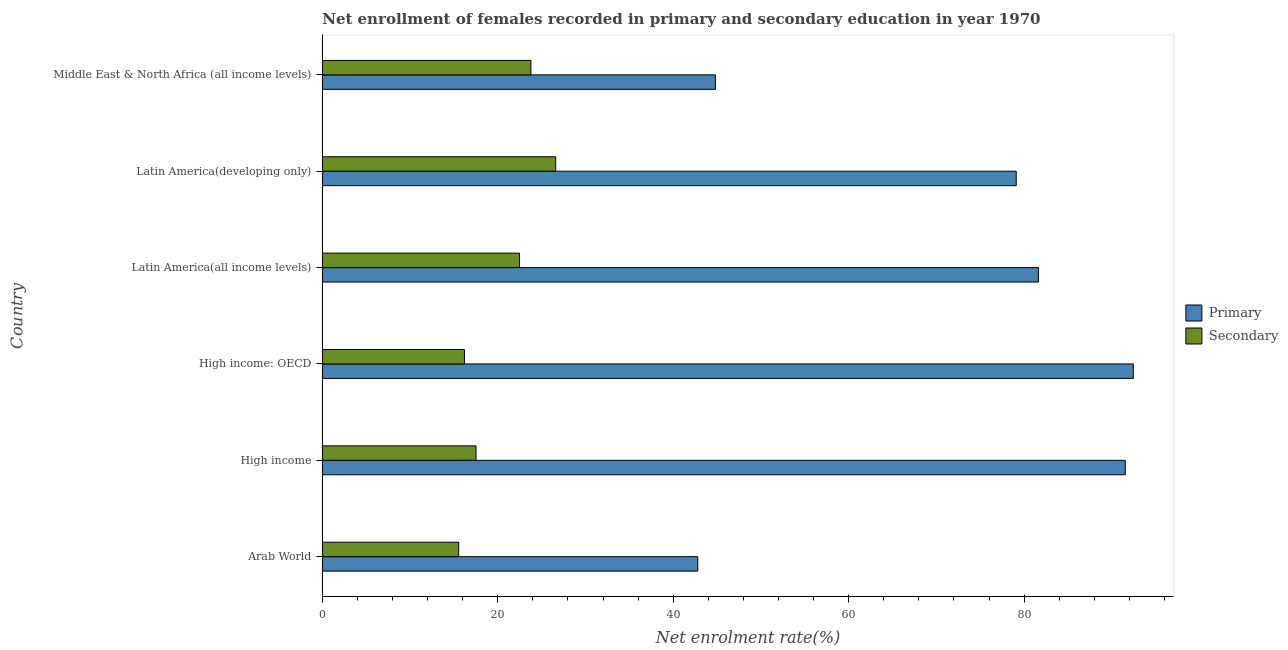How many different coloured bars are there?
Your answer should be compact. 2. Are the number of bars on each tick of the Y-axis equal?
Ensure brevity in your answer.  Yes. How many bars are there on the 2nd tick from the top?
Your answer should be very brief. 2. How many bars are there on the 6th tick from the bottom?
Offer a terse response. 2. What is the label of the 2nd group of bars from the top?
Offer a very short reply. Latin America(developing only). What is the enrollment rate in primary education in Arab World?
Give a very brief answer. 42.8. Across all countries, what is the maximum enrollment rate in primary education?
Give a very brief answer. 92.45. Across all countries, what is the minimum enrollment rate in secondary education?
Your answer should be very brief. 15.54. In which country was the enrollment rate in secondary education maximum?
Ensure brevity in your answer.  Latin America(developing only). In which country was the enrollment rate in primary education minimum?
Ensure brevity in your answer.  Arab World. What is the total enrollment rate in primary education in the graph?
Provide a succinct answer. 432.35. What is the difference between the enrollment rate in primary education in High income and that in Middle East & North Africa (all income levels)?
Keep it short and to the point. 46.72. What is the difference between the enrollment rate in primary education in High income and the enrollment rate in secondary education in Latin America(developing only)?
Offer a very short reply. 64.93. What is the average enrollment rate in primary education per country?
Offer a terse response. 72.06. What is the difference between the enrollment rate in primary education and enrollment rate in secondary education in Middle East & North Africa (all income levels)?
Your response must be concise. 21.04. In how many countries, is the enrollment rate in secondary education greater than 56 %?
Keep it short and to the point. 0. What is the ratio of the enrollment rate in secondary education in Latin America(all income levels) to that in Latin America(developing only)?
Your answer should be very brief. 0.84. Is the enrollment rate in secondary education in High income: OECD less than that in Middle East & North Africa (all income levels)?
Make the answer very short. Yes. What is the difference between the highest and the second highest enrollment rate in primary education?
Keep it short and to the point. 0.91. What is the difference between the highest and the lowest enrollment rate in primary education?
Ensure brevity in your answer.  49.65. What does the 2nd bar from the top in Latin America(all income levels) represents?
Offer a terse response. Primary. What does the 2nd bar from the bottom in Latin America(developing only) represents?
Offer a very short reply. Secondary. How many bars are there?
Give a very brief answer. 12. What is the difference between two consecutive major ticks on the X-axis?
Give a very brief answer. 20. Are the values on the major ticks of X-axis written in scientific E-notation?
Your answer should be compact. No. What is the title of the graph?
Keep it short and to the point. Net enrollment of females recorded in primary and secondary education in year 1970. Does "External balance on goods" appear as one of the legend labels in the graph?
Provide a short and direct response. No. What is the label or title of the X-axis?
Your response must be concise. Net enrolment rate(%). What is the Net enrolment rate(%) of Primary in Arab World?
Provide a short and direct response. 42.8. What is the Net enrolment rate(%) in Secondary in Arab World?
Your answer should be very brief. 15.54. What is the Net enrolment rate(%) in Primary in High income?
Your answer should be compact. 91.54. What is the Net enrolment rate(%) of Secondary in High income?
Your answer should be very brief. 17.52. What is the Net enrolment rate(%) in Primary in High income: OECD?
Offer a very short reply. 92.45. What is the Net enrolment rate(%) in Secondary in High income: OECD?
Give a very brief answer. 16.2. What is the Net enrolment rate(%) of Primary in Latin America(all income levels)?
Offer a terse response. 81.63. What is the Net enrolment rate(%) in Secondary in Latin America(all income levels)?
Your answer should be very brief. 22.48. What is the Net enrolment rate(%) in Primary in Latin America(developing only)?
Ensure brevity in your answer.  79.11. What is the Net enrolment rate(%) in Secondary in Latin America(developing only)?
Offer a very short reply. 26.61. What is the Net enrolment rate(%) of Primary in Middle East & North Africa (all income levels)?
Provide a succinct answer. 44.82. What is the Net enrolment rate(%) of Secondary in Middle East & North Africa (all income levels)?
Offer a very short reply. 23.78. Across all countries, what is the maximum Net enrolment rate(%) in Primary?
Make the answer very short. 92.45. Across all countries, what is the maximum Net enrolment rate(%) of Secondary?
Offer a terse response. 26.61. Across all countries, what is the minimum Net enrolment rate(%) in Primary?
Your answer should be compact. 42.8. Across all countries, what is the minimum Net enrolment rate(%) of Secondary?
Give a very brief answer. 15.54. What is the total Net enrolment rate(%) of Primary in the graph?
Your answer should be very brief. 432.35. What is the total Net enrolment rate(%) of Secondary in the graph?
Make the answer very short. 122.13. What is the difference between the Net enrolment rate(%) of Primary in Arab World and that in High income?
Your answer should be very brief. -48.73. What is the difference between the Net enrolment rate(%) of Secondary in Arab World and that in High income?
Ensure brevity in your answer.  -1.98. What is the difference between the Net enrolment rate(%) in Primary in Arab World and that in High income: OECD?
Provide a short and direct response. -49.65. What is the difference between the Net enrolment rate(%) in Secondary in Arab World and that in High income: OECD?
Provide a short and direct response. -0.66. What is the difference between the Net enrolment rate(%) of Primary in Arab World and that in Latin America(all income levels)?
Make the answer very short. -38.83. What is the difference between the Net enrolment rate(%) in Secondary in Arab World and that in Latin America(all income levels)?
Your answer should be compact. -6.94. What is the difference between the Net enrolment rate(%) of Primary in Arab World and that in Latin America(developing only)?
Offer a terse response. -36.3. What is the difference between the Net enrolment rate(%) of Secondary in Arab World and that in Latin America(developing only)?
Your answer should be very brief. -11.06. What is the difference between the Net enrolment rate(%) in Primary in Arab World and that in Middle East & North Africa (all income levels)?
Offer a terse response. -2.01. What is the difference between the Net enrolment rate(%) in Secondary in Arab World and that in Middle East & North Africa (all income levels)?
Offer a terse response. -8.23. What is the difference between the Net enrolment rate(%) of Primary in High income and that in High income: OECD?
Your answer should be very brief. -0.91. What is the difference between the Net enrolment rate(%) of Secondary in High income and that in High income: OECD?
Provide a succinct answer. 1.32. What is the difference between the Net enrolment rate(%) of Primary in High income and that in Latin America(all income levels)?
Make the answer very short. 9.9. What is the difference between the Net enrolment rate(%) of Secondary in High income and that in Latin America(all income levels)?
Make the answer very short. -4.96. What is the difference between the Net enrolment rate(%) of Primary in High income and that in Latin America(developing only)?
Give a very brief answer. 12.43. What is the difference between the Net enrolment rate(%) in Secondary in High income and that in Latin America(developing only)?
Keep it short and to the point. -9.09. What is the difference between the Net enrolment rate(%) in Primary in High income and that in Middle East & North Africa (all income levels)?
Provide a short and direct response. 46.72. What is the difference between the Net enrolment rate(%) of Secondary in High income and that in Middle East & North Africa (all income levels)?
Make the answer very short. -6.26. What is the difference between the Net enrolment rate(%) of Primary in High income: OECD and that in Latin America(all income levels)?
Offer a terse response. 10.82. What is the difference between the Net enrolment rate(%) in Secondary in High income: OECD and that in Latin America(all income levels)?
Provide a succinct answer. -6.28. What is the difference between the Net enrolment rate(%) in Primary in High income: OECD and that in Latin America(developing only)?
Offer a very short reply. 13.35. What is the difference between the Net enrolment rate(%) in Secondary in High income: OECD and that in Latin America(developing only)?
Your response must be concise. -10.4. What is the difference between the Net enrolment rate(%) in Primary in High income: OECD and that in Middle East & North Africa (all income levels)?
Give a very brief answer. 47.63. What is the difference between the Net enrolment rate(%) in Secondary in High income: OECD and that in Middle East & North Africa (all income levels)?
Keep it short and to the point. -7.58. What is the difference between the Net enrolment rate(%) of Primary in Latin America(all income levels) and that in Latin America(developing only)?
Offer a very short reply. 2.53. What is the difference between the Net enrolment rate(%) in Secondary in Latin America(all income levels) and that in Latin America(developing only)?
Keep it short and to the point. -4.12. What is the difference between the Net enrolment rate(%) in Primary in Latin America(all income levels) and that in Middle East & North Africa (all income levels)?
Give a very brief answer. 36.82. What is the difference between the Net enrolment rate(%) in Secondary in Latin America(all income levels) and that in Middle East & North Africa (all income levels)?
Make the answer very short. -1.3. What is the difference between the Net enrolment rate(%) of Primary in Latin America(developing only) and that in Middle East & North Africa (all income levels)?
Ensure brevity in your answer.  34.29. What is the difference between the Net enrolment rate(%) of Secondary in Latin America(developing only) and that in Middle East & North Africa (all income levels)?
Your answer should be compact. 2.83. What is the difference between the Net enrolment rate(%) of Primary in Arab World and the Net enrolment rate(%) of Secondary in High income?
Your answer should be very brief. 25.28. What is the difference between the Net enrolment rate(%) in Primary in Arab World and the Net enrolment rate(%) in Secondary in High income: OECD?
Your answer should be very brief. 26.6. What is the difference between the Net enrolment rate(%) of Primary in Arab World and the Net enrolment rate(%) of Secondary in Latin America(all income levels)?
Your response must be concise. 20.32. What is the difference between the Net enrolment rate(%) of Primary in Arab World and the Net enrolment rate(%) of Secondary in Latin America(developing only)?
Ensure brevity in your answer.  16.2. What is the difference between the Net enrolment rate(%) of Primary in Arab World and the Net enrolment rate(%) of Secondary in Middle East & North Africa (all income levels)?
Ensure brevity in your answer.  19.03. What is the difference between the Net enrolment rate(%) in Primary in High income and the Net enrolment rate(%) in Secondary in High income: OECD?
Give a very brief answer. 75.34. What is the difference between the Net enrolment rate(%) of Primary in High income and the Net enrolment rate(%) of Secondary in Latin America(all income levels)?
Provide a short and direct response. 69.06. What is the difference between the Net enrolment rate(%) in Primary in High income and the Net enrolment rate(%) in Secondary in Latin America(developing only)?
Give a very brief answer. 64.93. What is the difference between the Net enrolment rate(%) of Primary in High income and the Net enrolment rate(%) of Secondary in Middle East & North Africa (all income levels)?
Your answer should be very brief. 67.76. What is the difference between the Net enrolment rate(%) of Primary in High income: OECD and the Net enrolment rate(%) of Secondary in Latin America(all income levels)?
Make the answer very short. 69.97. What is the difference between the Net enrolment rate(%) of Primary in High income: OECD and the Net enrolment rate(%) of Secondary in Latin America(developing only)?
Your response must be concise. 65.85. What is the difference between the Net enrolment rate(%) in Primary in High income: OECD and the Net enrolment rate(%) in Secondary in Middle East & North Africa (all income levels)?
Your answer should be compact. 68.68. What is the difference between the Net enrolment rate(%) of Primary in Latin America(all income levels) and the Net enrolment rate(%) of Secondary in Latin America(developing only)?
Your response must be concise. 55.03. What is the difference between the Net enrolment rate(%) in Primary in Latin America(all income levels) and the Net enrolment rate(%) in Secondary in Middle East & North Africa (all income levels)?
Offer a terse response. 57.86. What is the difference between the Net enrolment rate(%) of Primary in Latin America(developing only) and the Net enrolment rate(%) of Secondary in Middle East & North Africa (all income levels)?
Your answer should be very brief. 55.33. What is the average Net enrolment rate(%) of Primary per country?
Your response must be concise. 72.06. What is the average Net enrolment rate(%) in Secondary per country?
Your response must be concise. 20.36. What is the difference between the Net enrolment rate(%) in Primary and Net enrolment rate(%) in Secondary in Arab World?
Make the answer very short. 27.26. What is the difference between the Net enrolment rate(%) in Primary and Net enrolment rate(%) in Secondary in High income?
Make the answer very short. 74.02. What is the difference between the Net enrolment rate(%) of Primary and Net enrolment rate(%) of Secondary in High income: OECD?
Offer a very short reply. 76.25. What is the difference between the Net enrolment rate(%) in Primary and Net enrolment rate(%) in Secondary in Latin America(all income levels)?
Provide a short and direct response. 59.15. What is the difference between the Net enrolment rate(%) in Primary and Net enrolment rate(%) in Secondary in Latin America(developing only)?
Provide a succinct answer. 52.5. What is the difference between the Net enrolment rate(%) in Primary and Net enrolment rate(%) in Secondary in Middle East & North Africa (all income levels)?
Offer a terse response. 21.04. What is the ratio of the Net enrolment rate(%) of Primary in Arab World to that in High income?
Offer a very short reply. 0.47. What is the ratio of the Net enrolment rate(%) in Secondary in Arab World to that in High income?
Your answer should be compact. 0.89. What is the ratio of the Net enrolment rate(%) in Primary in Arab World to that in High income: OECD?
Provide a short and direct response. 0.46. What is the ratio of the Net enrolment rate(%) in Secondary in Arab World to that in High income: OECD?
Give a very brief answer. 0.96. What is the ratio of the Net enrolment rate(%) in Primary in Arab World to that in Latin America(all income levels)?
Give a very brief answer. 0.52. What is the ratio of the Net enrolment rate(%) in Secondary in Arab World to that in Latin America(all income levels)?
Give a very brief answer. 0.69. What is the ratio of the Net enrolment rate(%) of Primary in Arab World to that in Latin America(developing only)?
Offer a terse response. 0.54. What is the ratio of the Net enrolment rate(%) of Secondary in Arab World to that in Latin America(developing only)?
Offer a very short reply. 0.58. What is the ratio of the Net enrolment rate(%) in Primary in Arab World to that in Middle East & North Africa (all income levels)?
Give a very brief answer. 0.96. What is the ratio of the Net enrolment rate(%) of Secondary in Arab World to that in Middle East & North Africa (all income levels)?
Offer a terse response. 0.65. What is the ratio of the Net enrolment rate(%) in Primary in High income to that in High income: OECD?
Your answer should be compact. 0.99. What is the ratio of the Net enrolment rate(%) of Secondary in High income to that in High income: OECD?
Provide a short and direct response. 1.08. What is the ratio of the Net enrolment rate(%) of Primary in High income to that in Latin America(all income levels)?
Keep it short and to the point. 1.12. What is the ratio of the Net enrolment rate(%) in Secondary in High income to that in Latin America(all income levels)?
Keep it short and to the point. 0.78. What is the ratio of the Net enrolment rate(%) of Primary in High income to that in Latin America(developing only)?
Offer a terse response. 1.16. What is the ratio of the Net enrolment rate(%) in Secondary in High income to that in Latin America(developing only)?
Give a very brief answer. 0.66. What is the ratio of the Net enrolment rate(%) of Primary in High income to that in Middle East & North Africa (all income levels)?
Provide a short and direct response. 2.04. What is the ratio of the Net enrolment rate(%) in Secondary in High income to that in Middle East & North Africa (all income levels)?
Provide a succinct answer. 0.74. What is the ratio of the Net enrolment rate(%) in Primary in High income: OECD to that in Latin America(all income levels)?
Offer a terse response. 1.13. What is the ratio of the Net enrolment rate(%) in Secondary in High income: OECD to that in Latin America(all income levels)?
Give a very brief answer. 0.72. What is the ratio of the Net enrolment rate(%) of Primary in High income: OECD to that in Latin America(developing only)?
Provide a short and direct response. 1.17. What is the ratio of the Net enrolment rate(%) of Secondary in High income: OECD to that in Latin America(developing only)?
Offer a terse response. 0.61. What is the ratio of the Net enrolment rate(%) in Primary in High income: OECD to that in Middle East & North Africa (all income levels)?
Offer a very short reply. 2.06. What is the ratio of the Net enrolment rate(%) of Secondary in High income: OECD to that in Middle East & North Africa (all income levels)?
Your answer should be compact. 0.68. What is the ratio of the Net enrolment rate(%) in Primary in Latin America(all income levels) to that in Latin America(developing only)?
Ensure brevity in your answer.  1.03. What is the ratio of the Net enrolment rate(%) of Secondary in Latin America(all income levels) to that in Latin America(developing only)?
Offer a very short reply. 0.84. What is the ratio of the Net enrolment rate(%) in Primary in Latin America(all income levels) to that in Middle East & North Africa (all income levels)?
Your answer should be very brief. 1.82. What is the ratio of the Net enrolment rate(%) in Secondary in Latin America(all income levels) to that in Middle East & North Africa (all income levels)?
Offer a very short reply. 0.95. What is the ratio of the Net enrolment rate(%) in Primary in Latin America(developing only) to that in Middle East & North Africa (all income levels)?
Offer a terse response. 1.76. What is the ratio of the Net enrolment rate(%) of Secondary in Latin America(developing only) to that in Middle East & North Africa (all income levels)?
Make the answer very short. 1.12. What is the difference between the highest and the second highest Net enrolment rate(%) of Primary?
Offer a very short reply. 0.91. What is the difference between the highest and the second highest Net enrolment rate(%) in Secondary?
Your response must be concise. 2.83. What is the difference between the highest and the lowest Net enrolment rate(%) of Primary?
Ensure brevity in your answer.  49.65. What is the difference between the highest and the lowest Net enrolment rate(%) of Secondary?
Your answer should be compact. 11.06. 